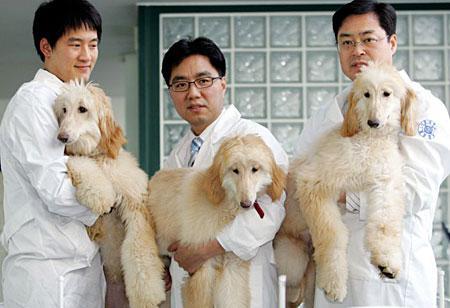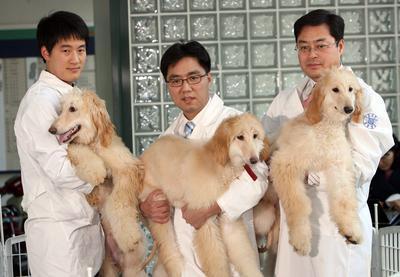The first image is the image on the left, the second image is the image on the right. For the images displayed, is the sentence "There are four dogs in total." factually correct? Answer yes or no. No. 